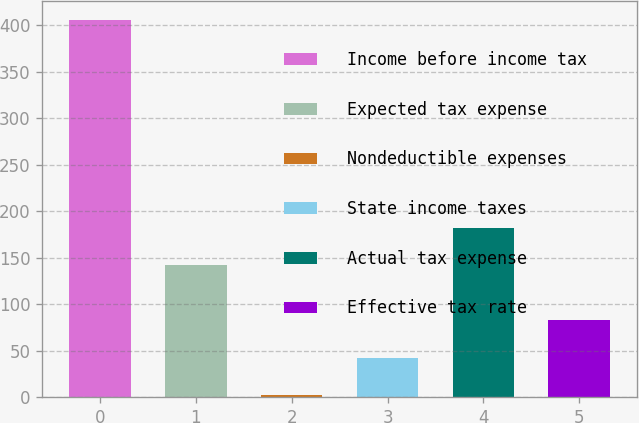<chart> <loc_0><loc_0><loc_500><loc_500><bar_chart><fcel>Income before income tax<fcel>Expected tax expense<fcel>Nondeductible expenses<fcel>State income taxes<fcel>Actual tax expense<fcel>Effective tax rate<nl><fcel>406<fcel>142<fcel>2<fcel>42.4<fcel>182.4<fcel>82.8<nl></chart> 